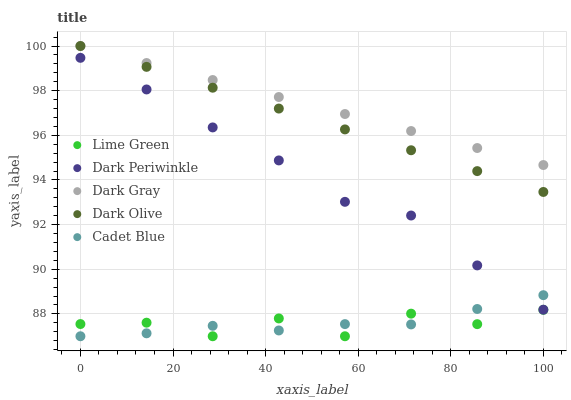Does Lime Green have the minimum area under the curve?
Answer yes or no. Yes. Does Dark Gray have the maximum area under the curve?
Answer yes or no. Yes. Does Dark Olive have the minimum area under the curve?
Answer yes or no. No. Does Dark Olive have the maximum area under the curve?
Answer yes or no. No. Is Dark Olive the smoothest?
Answer yes or no. Yes. Is Lime Green the roughest?
Answer yes or no. Yes. Is Lime Green the smoothest?
Answer yes or no. No. Is Dark Olive the roughest?
Answer yes or no. No. Does Lime Green have the lowest value?
Answer yes or no. Yes. Does Dark Olive have the lowest value?
Answer yes or no. No. Does Dark Olive have the highest value?
Answer yes or no. Yes. Does Lime Green have the highest value?
Answer yes or no. No. Is Lime Green less than Dark Gray?
Answer yes or no. Yes. Is Dark Periwinkle greater than Lime Green?
Answer yes or no. Yes. Does Cadet Blue intersect Dark Periwinkle?
Answer yes or no. Yes. Is Cadet Blue less than Dark Periwinkle?
Answer yes or no. No. Is Cadet Blue greater than Dark Periwinkle?
Answer yes or no. No. Does Lime Green intersect Dark Gray?
Answer yes or no. No. 